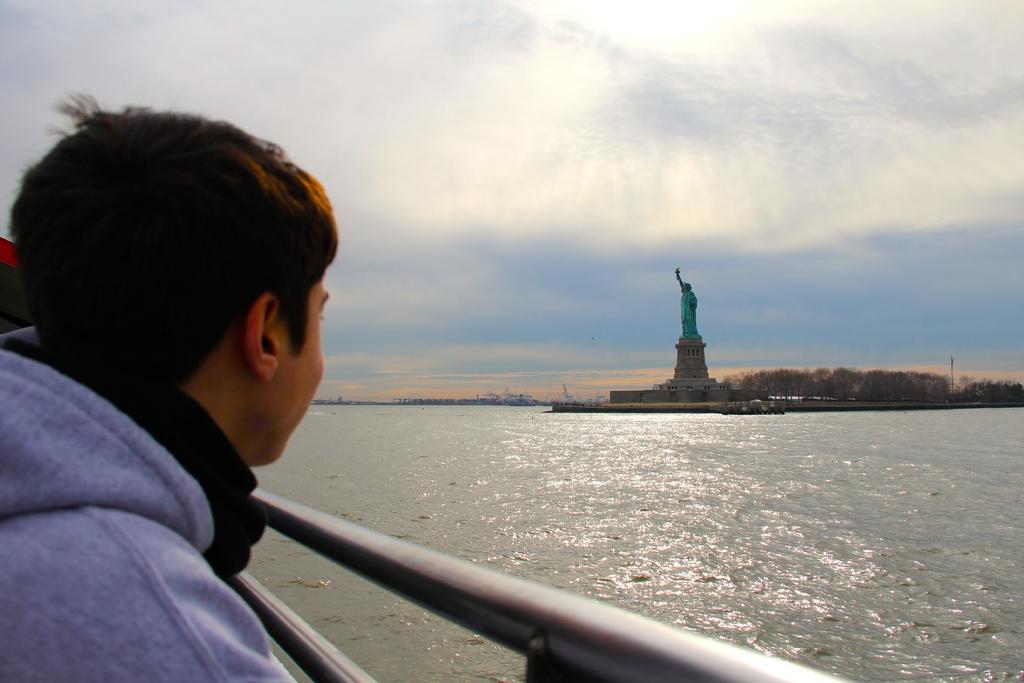In one or two sentences, can you explain what this image depicts? Completely an outdoor picture. Sky is cloudy. This is freshwater river. Far there is a statue in blue color. Far there are number of trees. Front this person is looking toward this statue. This is rod. 